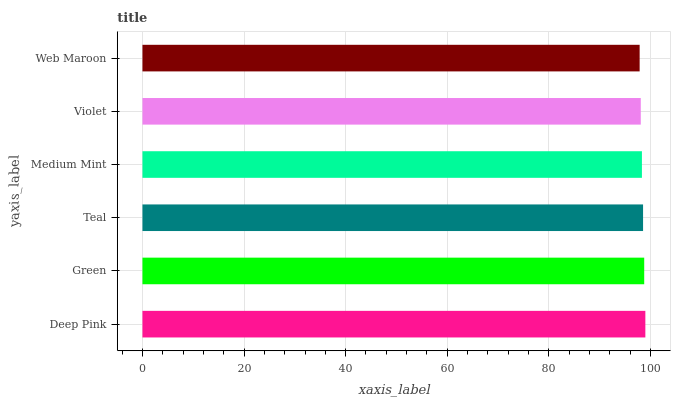Is Web Maroon the minimum?
Answer yes or no. Yes. Is Deep Pink the maximum?
Answer yes or no. Yes. Is Green the minimum?
Answer yes or no. No. Is Green the maximum?
Answer yes or no. No. Is Deep Pink greater than Green?
Answer yes or no. Yes. Is Green less than Deep Pink?
Answer yes or no. Yes. Is Green greater than Deep Pink?
Answer yes or no. No. Is Deep Pink less than Green?
Answer yes or no. No. Is Teal the high median?
Answer yes or no. Yes. Is Medium Mint the low median?
Answer yes or no. Yes. Is Web Maroon the high median?
Answer yes or no. No. Is Deep Pink the low median?
Answer yes or no. No. 